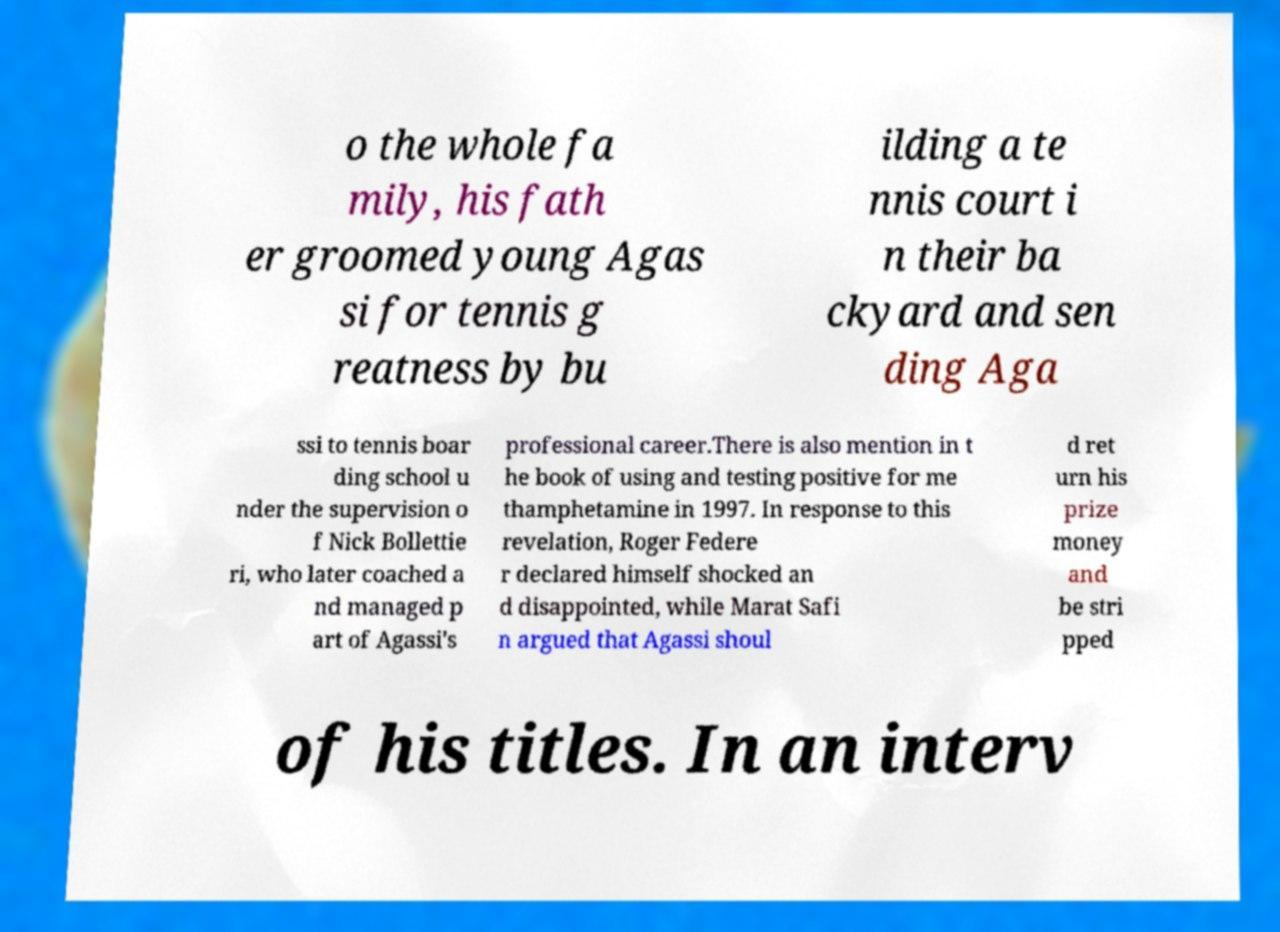Please read and relay the text visible in this image. What does it say? o the whole fa mily, his fath er groomed young Agas si for tennis g reatness by bu ilding a te nnis court i n their ba ckyard and sen ding Aga ssi to tennis boar ding school u nder the supervision o f Nick Bollettie ri, who later coached a nd managed p art of Agassi's professional career.There is also mention in t he book of using and testing positive for me thamphetamine in 1997. In response to this revelation, Roger Federe r declared himself shocked an d disappointed, while Marat Safi n argued that Agassi shoul d ret urn his prize money and be stri pped of his titles. In an interv 